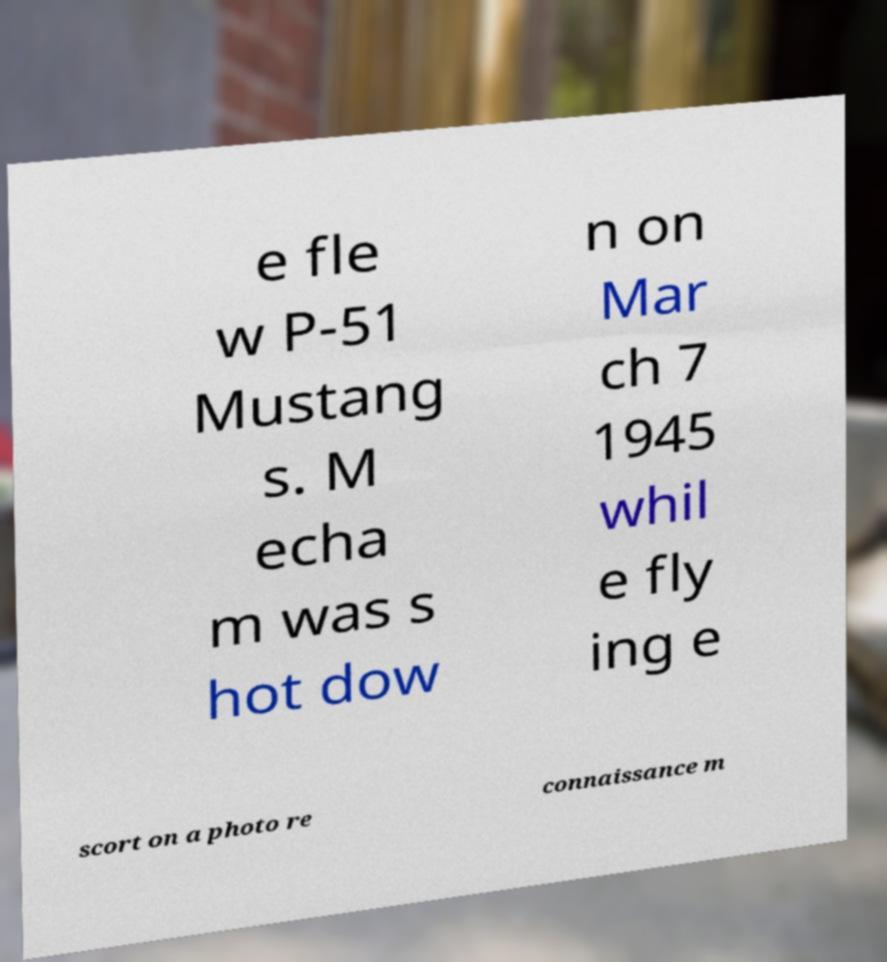Can you accurately transcribe the text from the provided image for me? e fle w P-51 Mustang s. M echa m was s hot dow n on Mar ch 7 1945 whil e fly ing e scort on a photo re connaissance m 